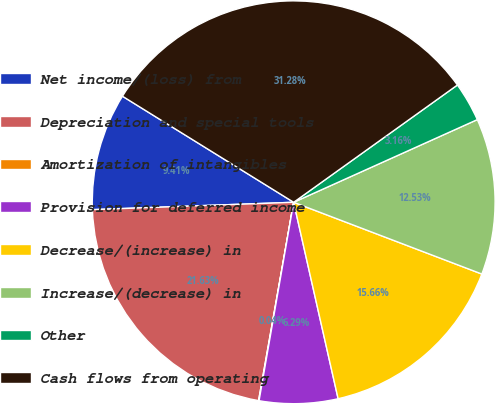Convert chart to OTSL. <chart><loc_0><loc_0><loc_500><loc_500><pie_chart><fcel>Net income/(loss) from<fcel>Depreciation and special tools<fcel>Amortization of intangibles<fcel>Provision for deferred income<fcel>Decrease/(increase) in<fcel>Increase/(decrease) in<fcel>Other<fcel>Cash flows from operating<nl><fcel>9.41%<fcel>21.63%<fcel>0.04%<fcel>6.29%<fcel>15.66%<fcel>12.53%<fcel>3.16%<fcel>31.28%<nl></chart> 